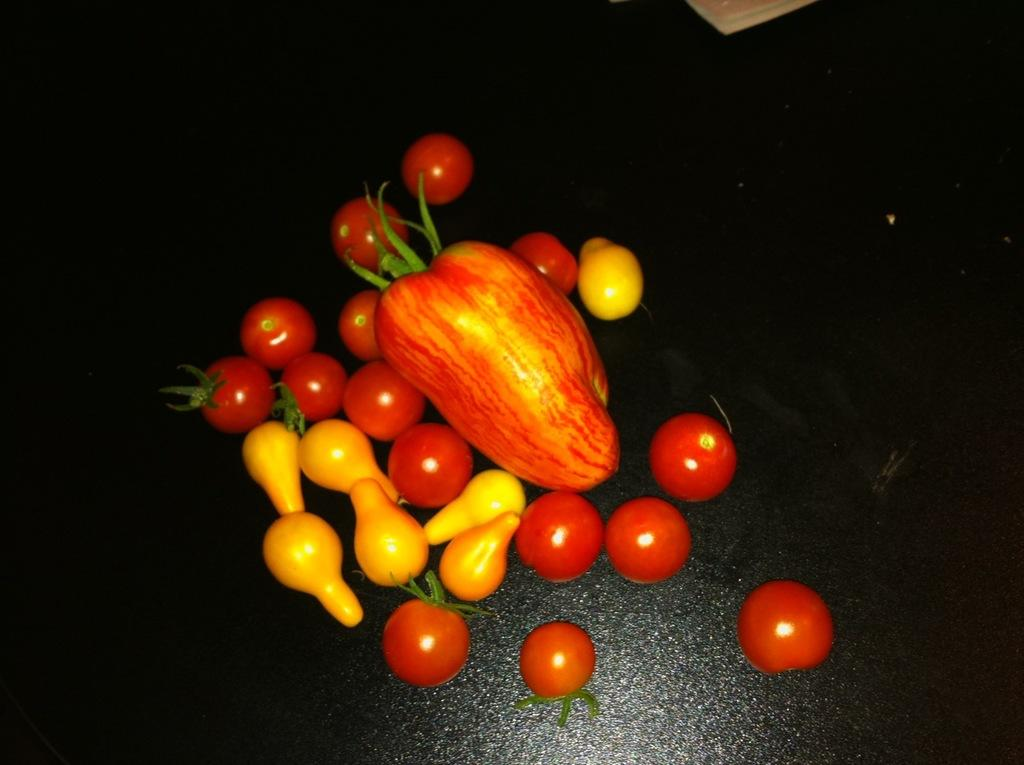What type of food is visible in the image? There are many fruits present in the image. Can you describe the variety of fruits in the image? Unfortunately, the facts provided do not specify the types of fruits present in the image. How are the fruits arranged or displayed in the image? Again, the facts provided do not give information about the arrangement or display of the fruits in the image. What type of canvas is visible in the image? There is no canvas present in the image; it features many fruits. How many cars can be seen driving through the orchard in the image? There is no orchard or cars present in the image; it features many fruits. 